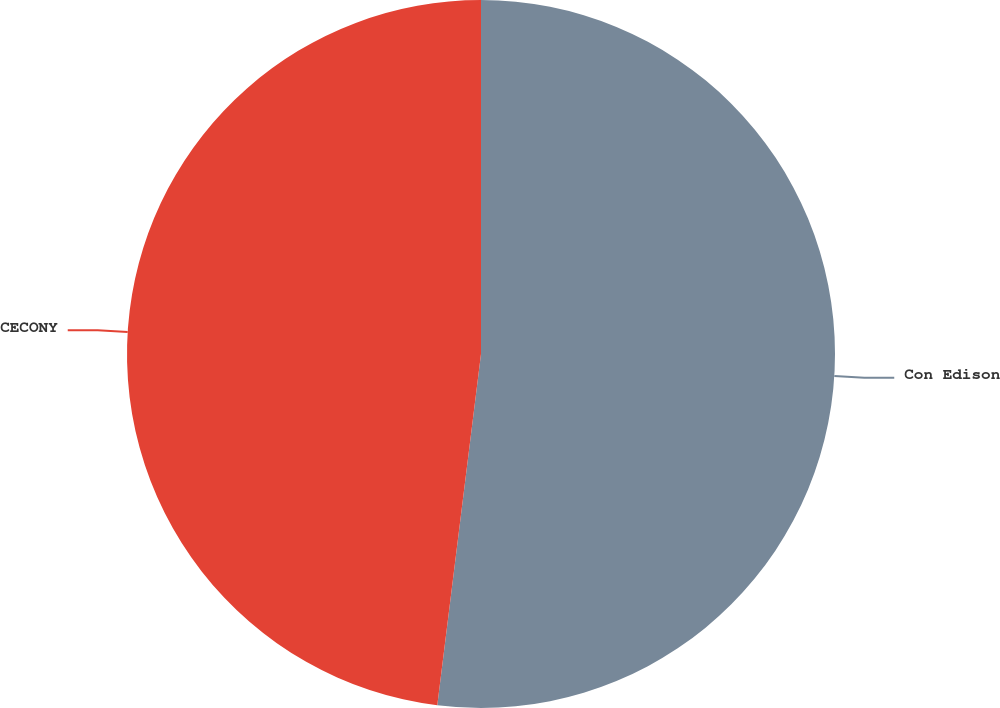<chart> <loc_0><loc_0><loc_500><loc_500><pie_chart><fcel>Con Edison<fcel>CECONY<nl><fcel>51.97%<fcel>48.03%<nl></chart> 